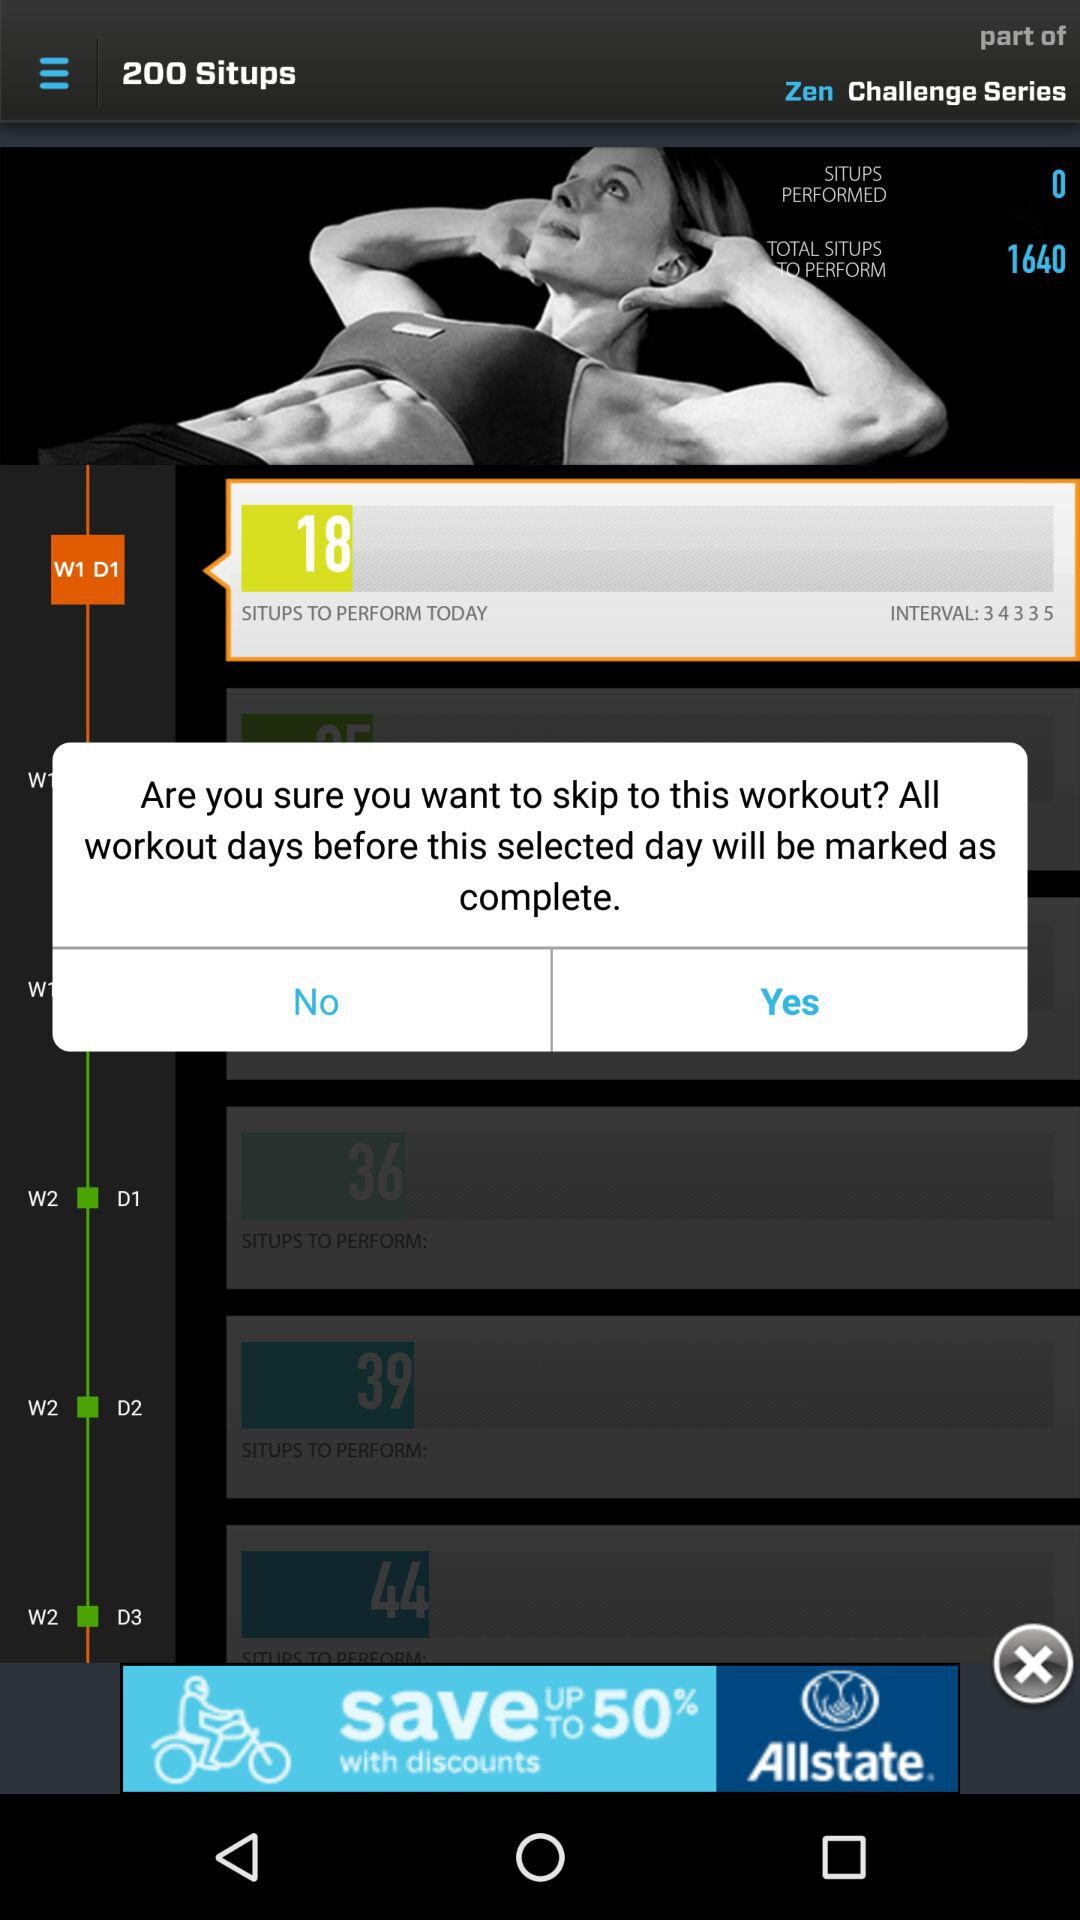What is the count of sit-ups on W1 D1? The count of sit-ups on W1 D1 is 18. 